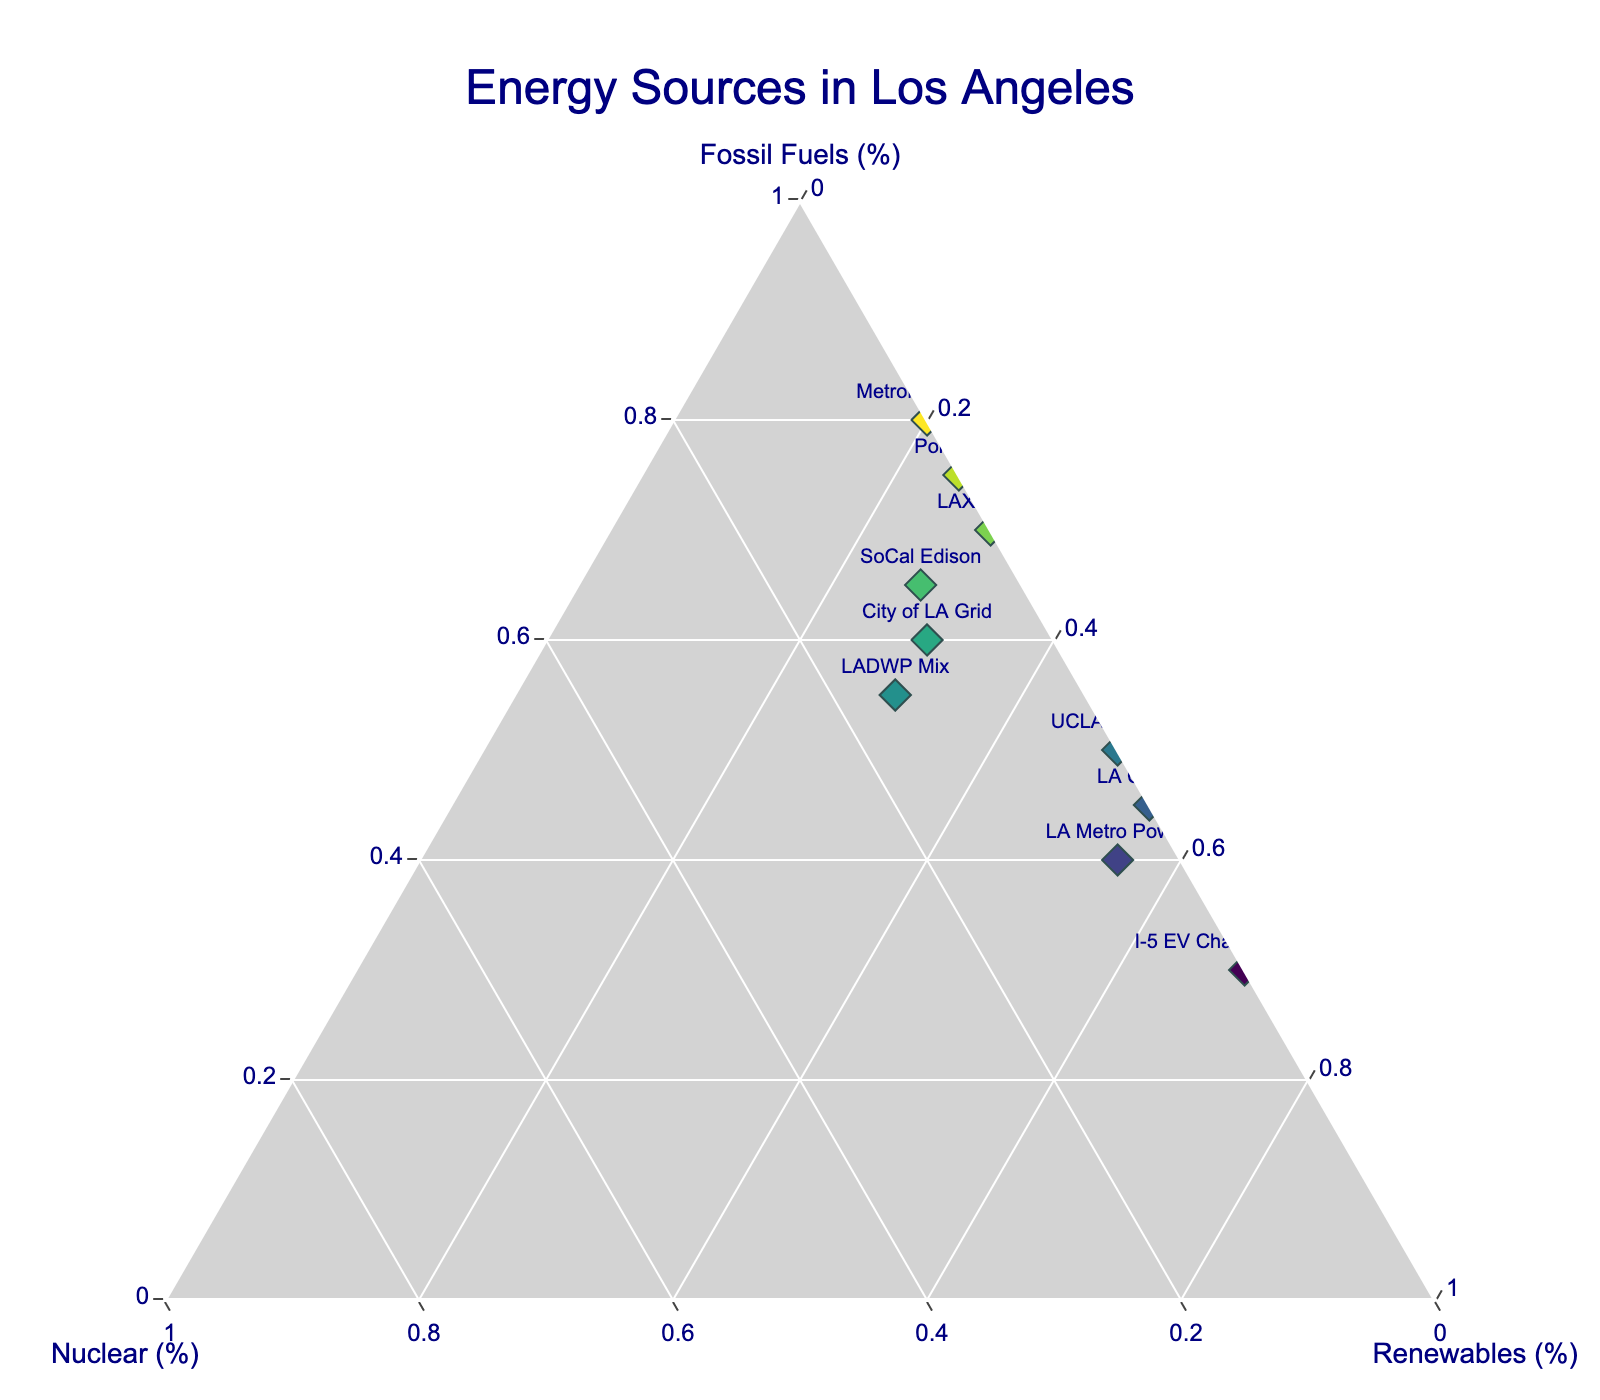What is the title of the plot? The title is displayed at the top center of the figure.
Answer: Energy Sources in Los Angeles How many energy sources are represented in the figure? Count the number of unique markers on the plot.
Answer: 10 Which energy source relies the most on renewables? Identify the data point with the highest value on the Renewables axis.
Answer: I-5 EV Charging Stations What is the sum of the contributions of fossil fuels and nuclear for the City of LA Grid? Add the percentages of fossil fuels and nuclear for the City of LA Grid (60 + 10).
Answer: 70 Compare the percentage of fossil fuels between SoCal Edison and LADWP Mix. Which is higher? Look at the fossil fuel values for SoCal Edison and LADWP Mix and compare them (65 vs 55).
Answer: SoCal Edison Which energy source has zero reliance on nuclear power? Identify data points where the percentage of nuclear is zero.
Answer: LAX Energy, Port of LA, UCLA Campus, LA City Hall, Metrolink Trains, I-5 EV Charging Stations What is the average contribution of fossil fuels for all the listed energy sources? Sum the fossil fuel percentages and divide by the number of sources (60 + 55 + 65 + 40 + 70 + 75 + 50 + 45 + 80 + 30) / 10.
Answer: 57 Which energy source has the smallest percentage of nuclear power among those that do utilize it? Find the data point with the non-zero nuclear percentage that is the smallest.
Answer: LA Metro Power Describe the distribution of renewable energy sources across the represented entities. Count the number of entities in different ranges of renewable energy percentages: high (over 50%), medium (25-50%), low (under 25%).
Answer: High (4), Medium (4), Low (2) If UCLA Campus added nuclear power to their energy mix, what would be the impact on their positioning in the ternary plot? Speculate on how adding a new component (nuclear) would shift the data point from the Renewables-Fossil Fuels line towards a new balance within the ternary space.
Answer: The point would shift towards the nuclear axis, balancing the contribution of renewables and fossil fuels 